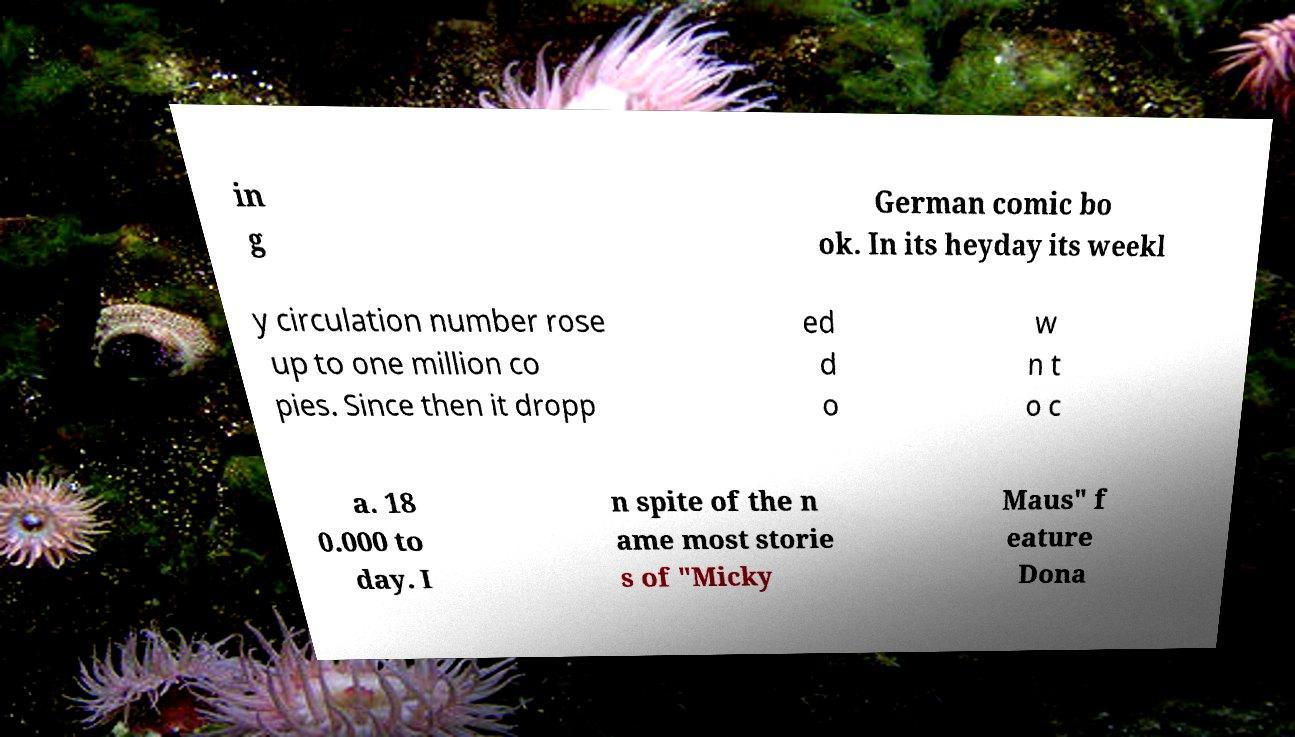For documentation purposes, I need the text within this image transcribed. Could you provide that? in g German comic bo ok. In its heyday its weekl y circulation number rose up to one million co pies. Since then it dropp ed d o w n t o c a. 18 0.000 to day. I n spite of the n ame most storie s of "Micky Maus" f eature Dona 